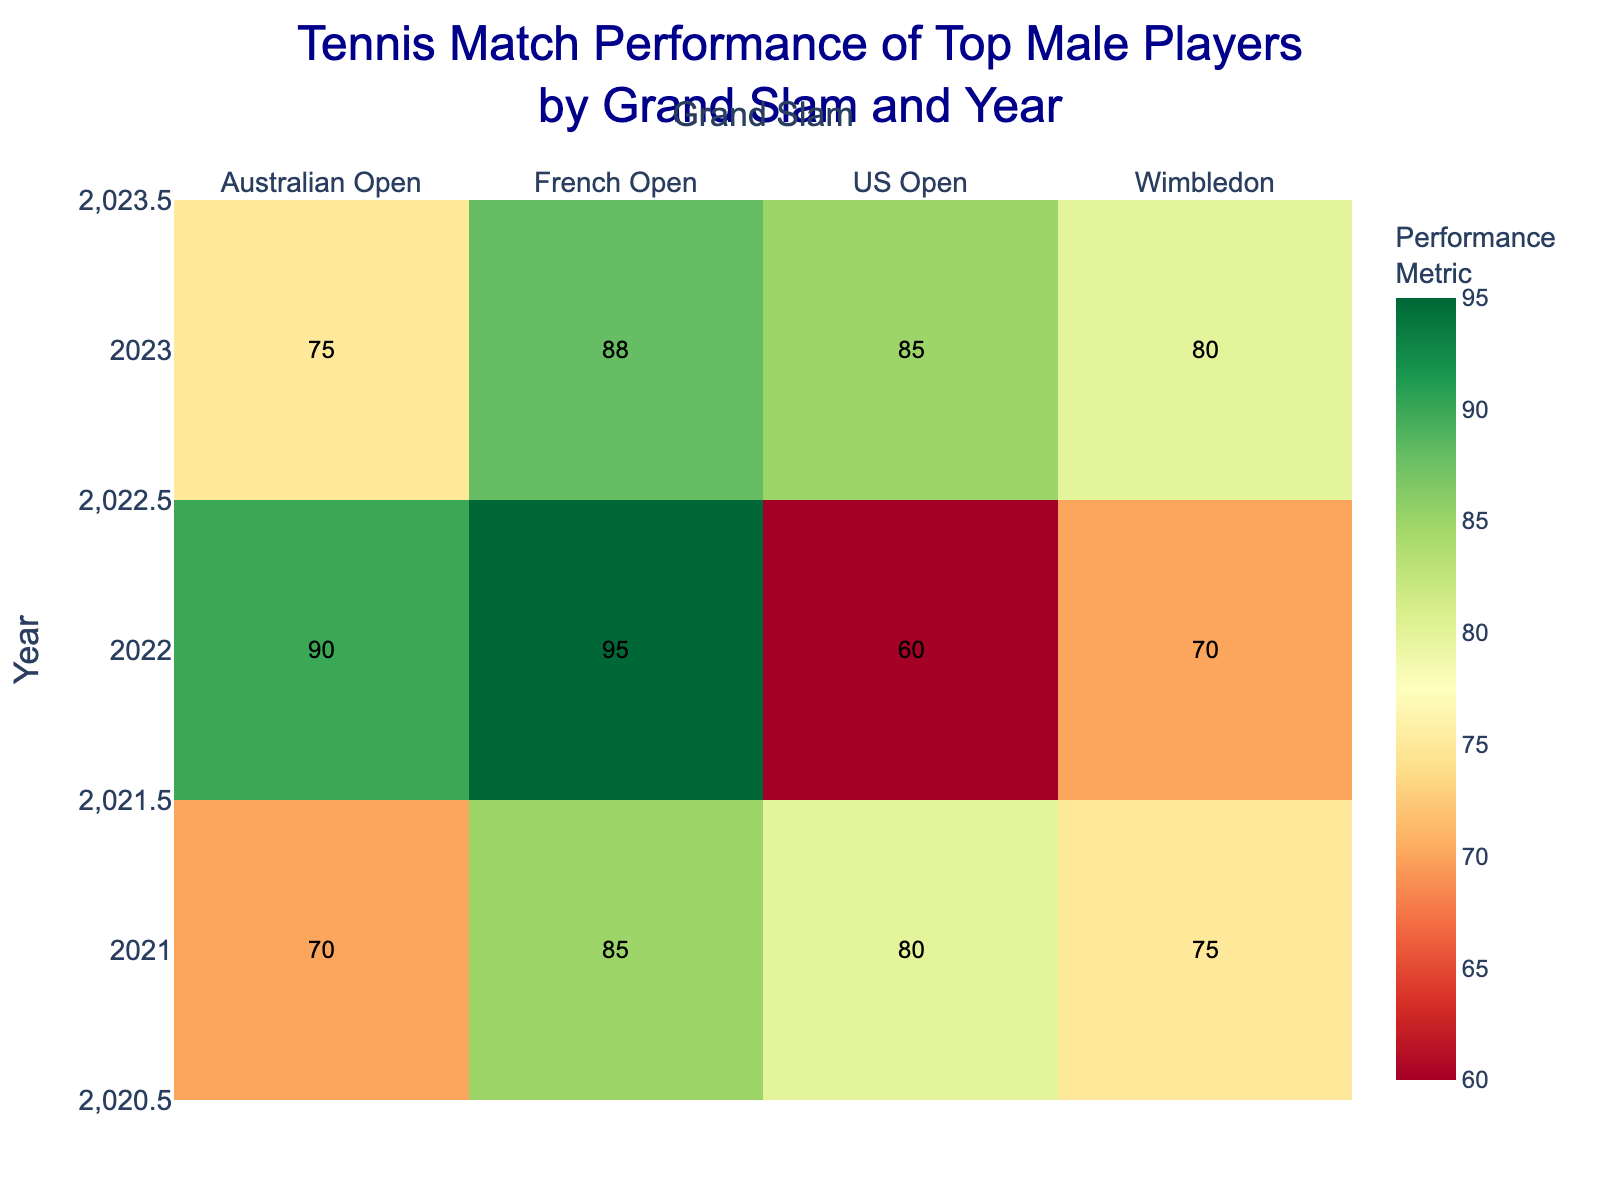What's the title of the heatmap? The title is usually found at the top of the figure and aims to succinctly describe what the heatmap represents. In this case, it is placed prominently to give a clear idea of the visualized dataset.
Answer: Tennis Match Performance of Top Male Players by Grand Slam and Year Which Grand Slam in 2022 had the highest performance metric? To determine this, look at the row for the year 2022 and compare the performance metrics across the four Grand Slam columns. The highest performance metric in this row will indicate the Grand Slam.
Answer: French Open What trend in performance metrics can you observe for Rafael Nadal in the French Open from 2021 to 2023? Look at the cells corresponding to the French Open for the years 2021, 2022, and 2023 in the heatmap. Note the color and the numerical values to identify any increasing, decreasing, or stable trends.
Answer: Increasing trend Which player had the lowest performance metric in the data, and in which year and Grand Slam did it happen? Find the cell with the lowest performance metric by scanning through the heatmap values. Note the corresponding year and Grand Slam.
Answer: Alexander Zverev, 2022 US Open Compare the performance metrics for Novak Djokovic in the Australian Open and US Open in 2023. Which one is higher? Locate Novak Djokovic's performance metrics for both the Australian Open and the US Open in 2023, then compare the two values.
Answer: US Open What is the overall performance metric trend for the Wimbledon Grand Slam from 2021 to 2023? Look at the cells corresponding to Wimbledon in the years 2021, 2022, and 2023 to observe the changing values or colors to identify any trends.
Answer: Increasing trend Which year had the highest average performance metric across all Grand Slams? Sum the performance metrics for each year and then divide by the number of Grand Slams (4) to get the average. Do this for each year to find which has the highest average.
Answer: 2022 How does Rafael Nadal's performance in the 2023 Australian Open compare to his 2021 French Open performance? Locate the specific cells for the 2023 Australian Open and 2021 French Open in the heatmap, and compare their values.
Answer: Lower in 2023 Which Grand Slam showed the most significant improvement in performance metric from 2022 to 2023? Compare the performance metrics for each Grand Slam between 2022 and 2023 and identify the one with the largest increase in value.
Answer: US Open What can you infer about the performance of players in the finals of the Australian Open over the three years shown? Examine the performance metrics for the Australian Open in 2021, 2022, and 2023 to identify any pattern, whether the performance is improving, declining, or remaining stable.
Answer: Variable trend with a peak in 2022 